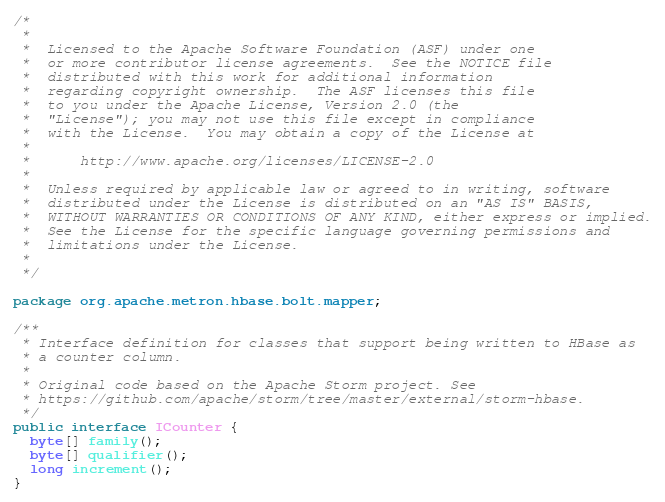Convert code to text. <code><loc_0><loc_0><loc_500><loc_500><_Java_>/*
 *
 *  Licensed to the Apache Software Foundation (ASF) under one
 *  or more contributor license agreements.  See the NOTICE file
 *  distributed with this work for additional information
 *  regarding copyright ownership.  The ASF licenses this file
 *  to you under the Apache License, Version 2.0 (the
 *  "License"); you may not use this file except in compliance
 *  with the License.  You may obtain a copy of the License at
 *
 *      http://www.apache.org/licenses/LICENSE-2.0
 *
 *  Unless required by applicable law or agreed to in writing, software
 *  distributed under the License is distributed on an "AS IS" BASIS,
 *  WITHOUT WARRANTIES OR CONDITIONS OF ANY KIND, either express or implied.
 *  See the License for the specific language governing permissions and
 *  limitations under the License.
 *
 */

package org.apache.metron.hbase.bolt.mapper;

/**
 * Interface definition for classes that support being written to HBase as
 * a counter column.
 *
 * Original code based on the Apache Storm project. See
 * https://github.com/apache/storm/tree/master/external/storm-hbase.
 */
public interface ICounter {
  byte[] family();
  byte[] qualifier();
  long increment();
}</code> 